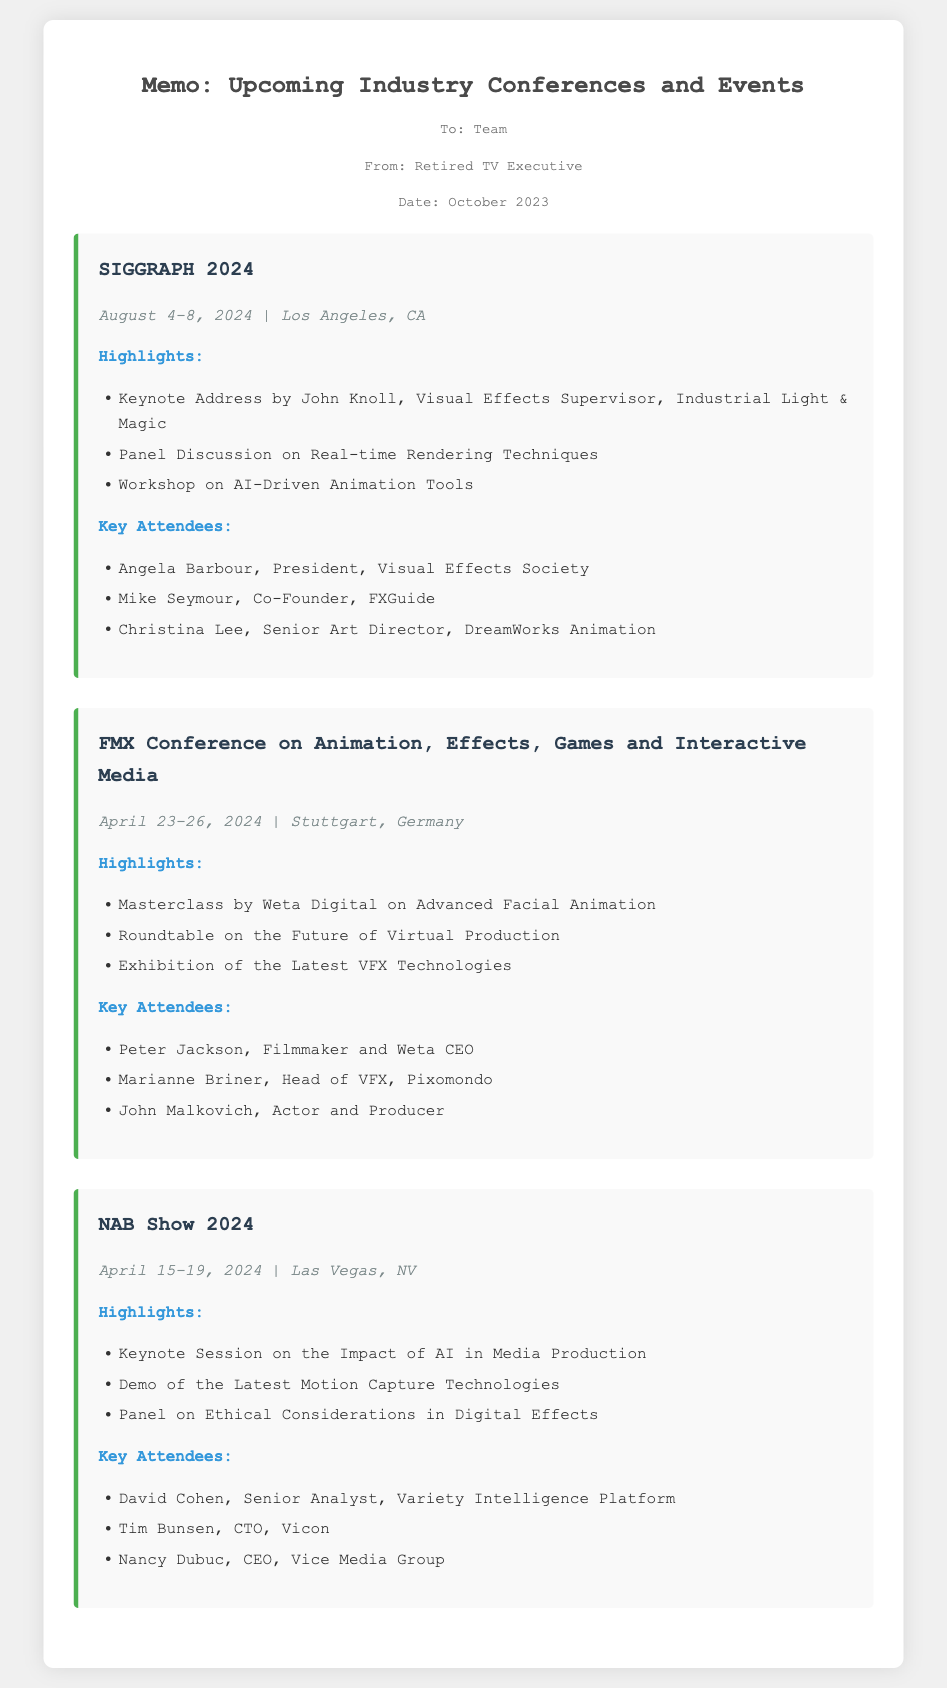What are the dates for SIGGRAPH 2024? The document states that SIGGRAPH 2024 takes place from August 4 to August 8, 2024.
Answer: August 4-8, 2024 Who is giving the keynote address at SIGGRAPH 2024? The keynote address at SIGGRAPH 2024 is given by John Knoll, Visual Effects Supervisor at Industrial Light & Magic.
Answer: John Knoll What city will the FMX Conference be held in? The FMX Conference will take place in Stuttgart, Germany.
Answer: Stuttgart, Germany What is one of the highlights at NAB Show 2024? One of the highlights at NAB Show 2024 is the Keynote Session on the Impact of AI in Media Production.
Answer: Keynote Session on the Impact of AI in Media Production Who is a key attendee at the FMX Conference? The document lists Peter Jackson, Filmmaker and Weta CEO, as a key attendee at the FMX Conference.
Answer: Peter Jackson Which conference features a workshop on AI-Driven Animation Tools? The conference that features a workshop on AI-Driven Animation Tools is SIGGRAPH 2024.
Answer: SIGGRAPH 2024 What organization is Angela Barbour associated with? Angela Barbour is the President of the Visual Effects Society.
Answer: Visual Effects Society How many main events are detailed in the memo? The memo details three main events: SIGGRAPH, FMX Conference, and NAB Show.
Answer: Three What type of event is the FMX Conference categorized as? The FMX Conference is categorized as focusing on Animation, Effects, Games, and Interactive Media.
Answer: Animation, Effects, Games and Interactive Media 